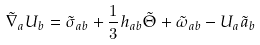Convert formula to latex. <formula><loc_0><loc_0><loc_500><loc_500>\tilde { \nabla } _ { a } U _ { b } = \tilde { \sigma } _ { a b } + \frac { 1 } { 3 } h _ { a b } \tilde { \Theta } + \tilde { \omega } _ { a b } - U _ { a } \tilde { a } _ { b }</formula> 